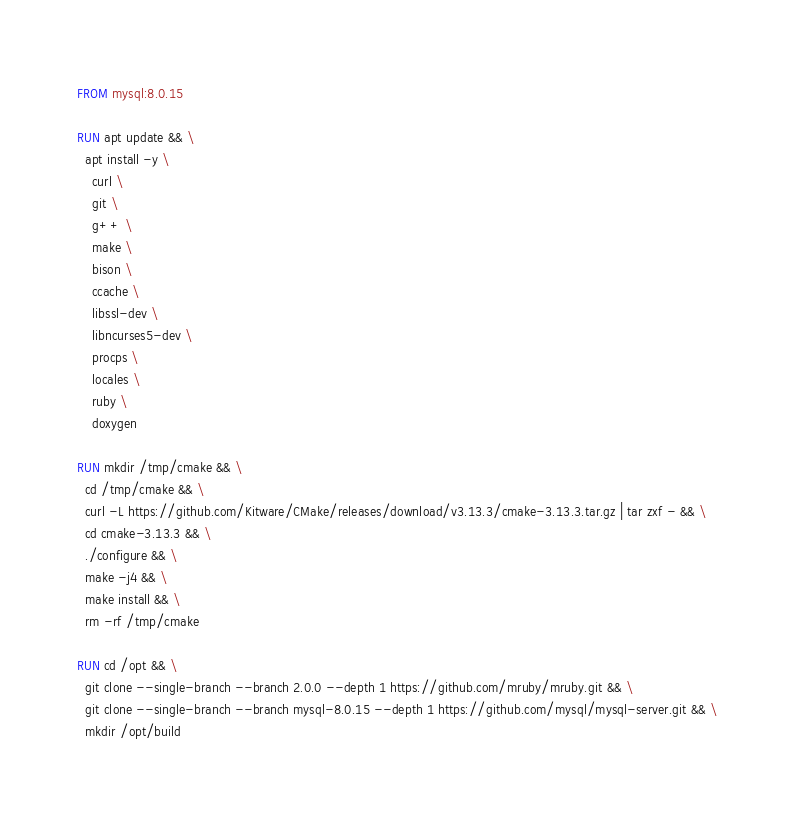Convert code to text. <code><loc_0><loc_0><loc_500><loc_500><_Dockerfile_>FROM mysql:8.0.15

RUN apt update && \
  apt install -y \
    curl \
    git \
    g++ \
    make \
    bison \
    ccache \
    libssl-dev \
    libncurses5-dev \
    procps \
    locales \
    ruby \
    doxygen

RUN mkdir /tmp/cmake && \
  cd /tmp/cmake && \
  curl -L https://github.com/Kitware/CMake/releases/download/v3.13.3/cmake-3.13.3.tar.gz | tar zxf - && \
  cd cmake-3.13.3 && \
  ./configure && \
  make -j4 && \
  make install && \
  rm -rf /tmp/cmake

RUN cd /opt && \
  git clone --single-branch --branch 2.0.0 --depth 1 https://github.com/mruby/mruby.git && \
  git clone --single-branch --branch mysql-8.0.15 --depth 1 https://github.com/mysql/mysql-server.git && \
  mkdir /opt/build
</code> 